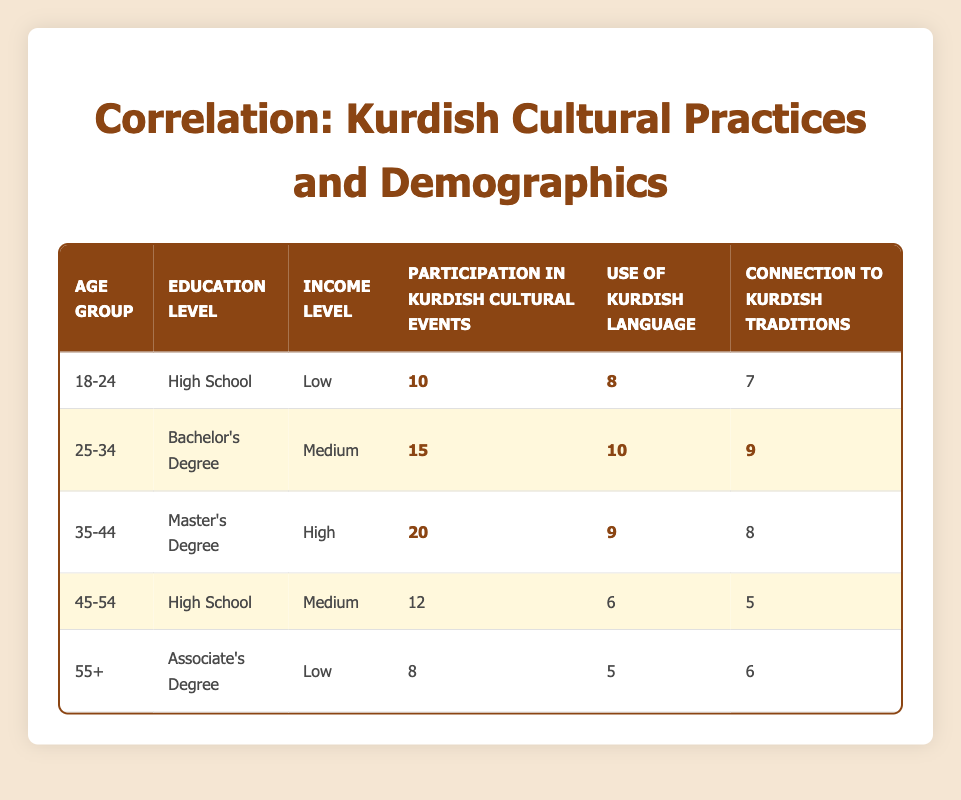What is the highest level of participation in Kurdish cultural events? The highest participation recorded is for the age group 35-44, where the participation in Kurdish cultural events is 20.
Answer: 20 Which age group has the lowest use of the Kurdish language? Among the groups, the 55+ age group has the lowest reported use of the Kurdish language, with a score of 5.
Answer: 5 What is the average connection to Kurdish traditions across all age groups? To compute the average, sum the values of connection to Kurdish traditions: (7 + 9 + 8 + 5 + 6) = 35. With 5 data points, the average is 35/5 = 7.
Answer: 7 Is there a correlation between education level and participation in Kurdish cultural events? Observing the table, it seems that higher education levels (Bachelor's degree and Master's degree) correspond to higher participation rates, indicating a positive correlation.
Answer: Yes Which income level has the second-highest average participation in Kurdish cultural events? The participation scores for each income level are as follows: Low (10+8)/2 = 9, Medium (15+12)/2 = 13.5, High (20)/1 = 20. Medium has the second-highest average participation at 13.5.
Answer: Medium What is the difference in participation in Kurdish cultural events between the 25-34 age group and the 45-54 age group? Participation for the 25-34 group is 15, and for the 45-54 group is 12. The difference is 15 - 12 = 3.
Answer: 3 Does anyone in the age group 18-24 have a higher connection to Kurdish traditions than 7? The 18-24 age group's connection to Kurdish traditions is exactly 7, meaning there is no one with a higher score in that group.
Answer: No How many people aged 35-44 participate in Kurdish cultural events? The table shows that there are 20 individuals aged 35-44 participating in Kurdish cultural events.
Answer: 20 What is the sum of the Kurdish language use scores for all age groups? Adding up the use of the Kurdish language for all groups gives (8 + 10 + 9 + 6 + 5) = 38.
Answer: 38 